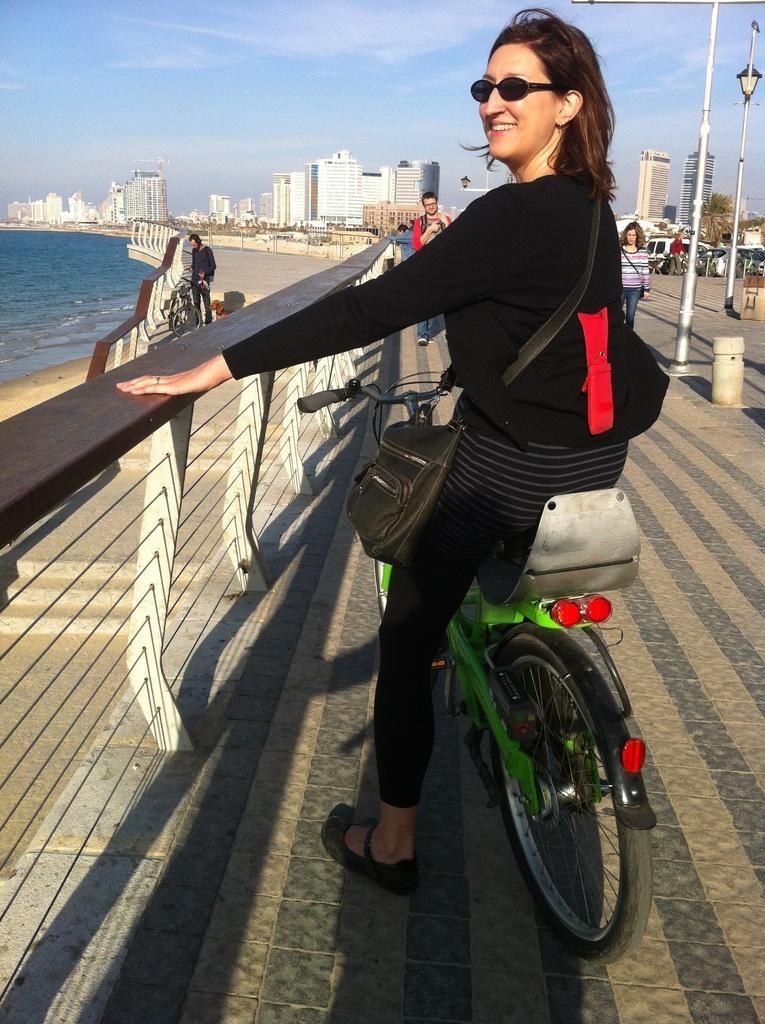Please provide a concise description of this image. Here we can see a woman sitting on her bicycle , she is having a bag and goggles and in front of her we can see people walking , there are buildings present far away and the sky is clear 